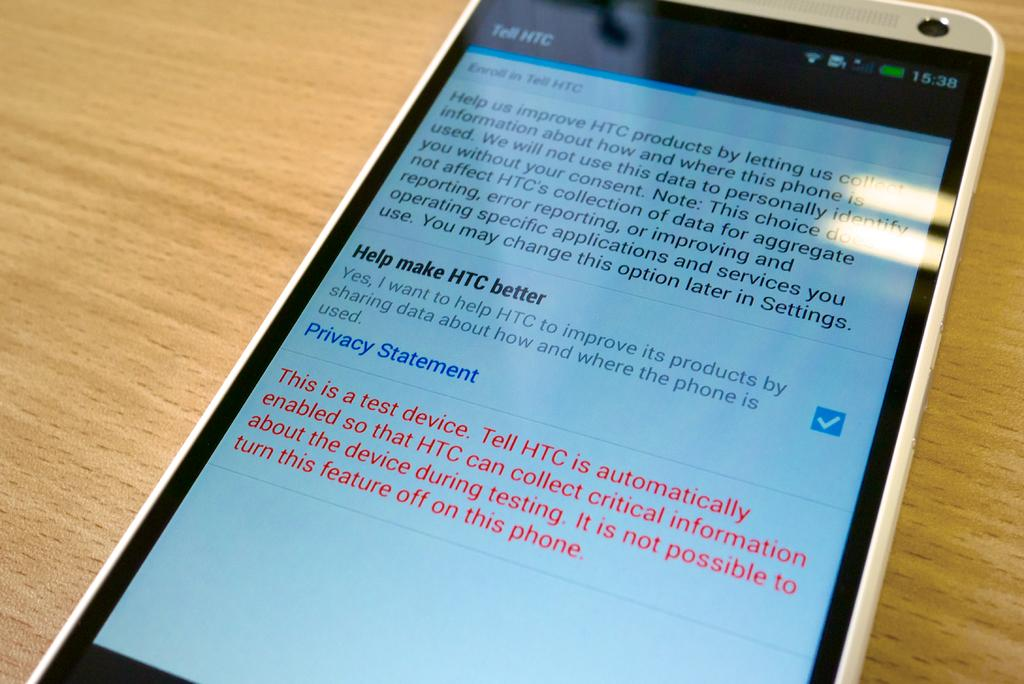<image>
Provide a brief description of the given image. Cellphone screen showing an email that asks how to make HTC better. 